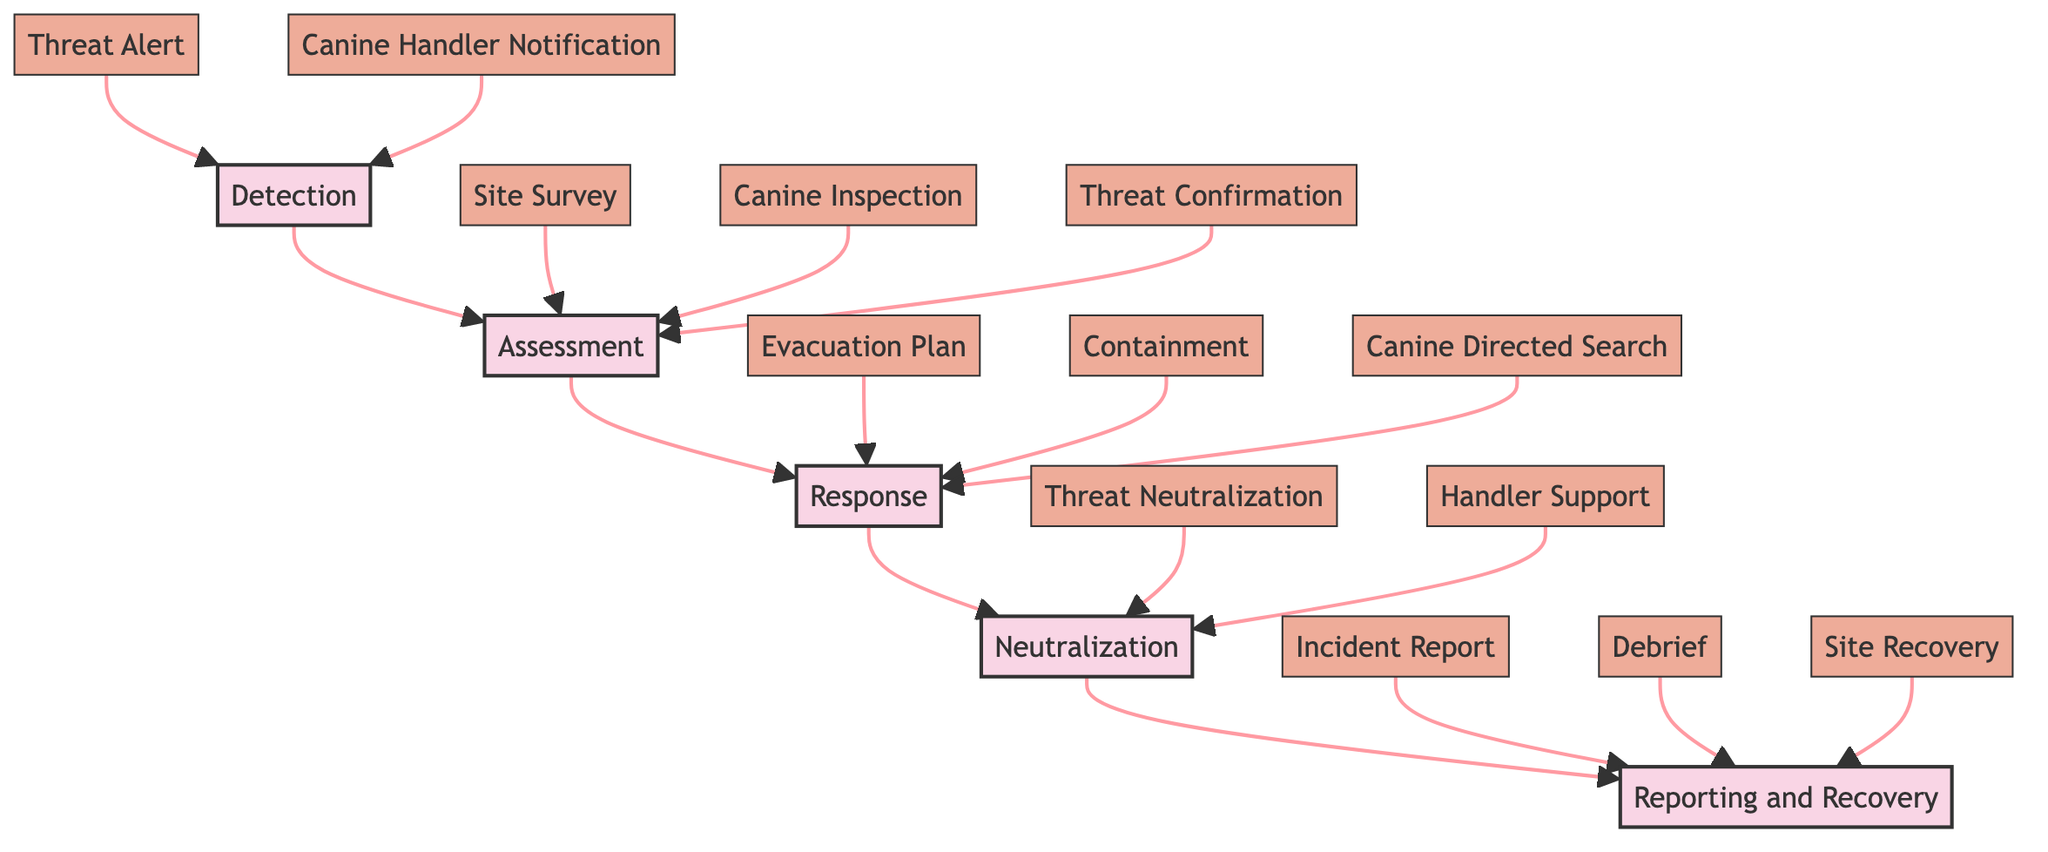What is the first step in the incident response process? The diagram shows that the first step in the incident response process is "Detection." This is represented at the top of the flow from which the subsequent phases branch out.
Answer: Detection How many steps are there in the Assessment phase? In the diagram, the Assessment phase has three steps linked to it: "Site Survey," "Canine Inspection," and "Threat Confirmation." By counting these nodes, we find that there are three steps in this phase.
Answer: 3 What follows the Response phase? According to the diagram flow, the Response phase is followed directly by the Neutralization phase, indicating the sequential nature of the incident response process.
Answer: Neutralization What is the last step in the process? The final phase of the process in the diagram is "Reporting and Recovery," which is depicted at the bottom and follows the Neutralization phase. This is where incident details are documented and recovery begins.
Answer: Reporting and Recovery What action is taken if a threat is confirmed? The diagram indicates that if a threat is confirmed during the Assessment phase, the next action outlined in the Response phase is to initiate an "Evacuation Plan." This highlights the immediate response intended for ensuring safety.
Answer: Initiate Evacuation How many total phases are in the incident response process? The diagram clearly delineates five phases in the incident response process, which are "Detection," "Assessment," "Response," "Neutralization," and "Reporting and Recovery." By simply counting these phases, the total is determined.
Answer: 5 What role does the canine handler play after threat neutralization? Following "Threat Neutralization," the diagram shows a connection to "Handler Support," indicating the role of the canine handler is to receive backup support to ensure safety and operational effectiveness after a threat has been neutralized.
Answer: Provide Backup Support What is conducted after the incident report? The diagram illustrates that after the "Incident Report" step in the Reporting and Recovery phase, a "Debrief" is conducted with the canine handler and team, emphasizing the importance of teamwork and communication post-incident.
Answer: Conduct Incident Debrief What type of survey is performed during the Assessment phase? The assessment phase includes a specific action called "Site Survey," which is indicated in the diagram and serves as an initial evaluation of the threat environment.
Answer: Initial Site Survey 